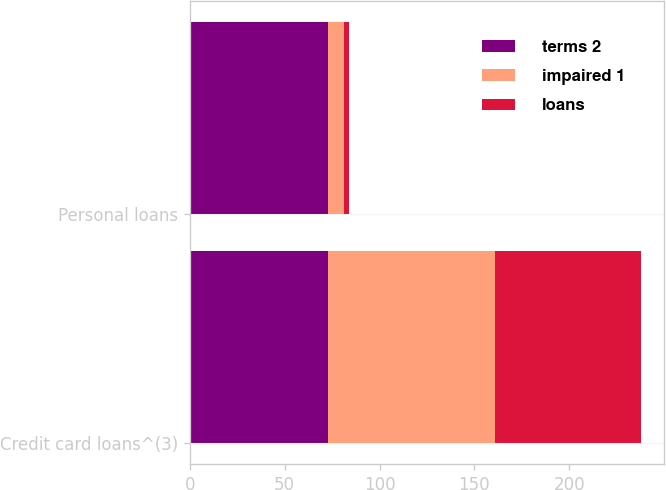Convert chart. <chart><loc_0><loc_0><loc_500><loc_500><stacked_bar_chart><ecel><fcel>Credit card loans^(3)<fcel>Personal loans<nl><fcel>terms 2<fcel>73<fcel>73<nl><fcel>impaired 1<fcel>88<fcel>8<nl><fcel>loans<fcel>77<fcel>3<nl></chart> 